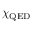Convert formula to latex. <formula><loc_0><loc_0><loc_500><loc_500>\chi _ { Q E D }</formula> 